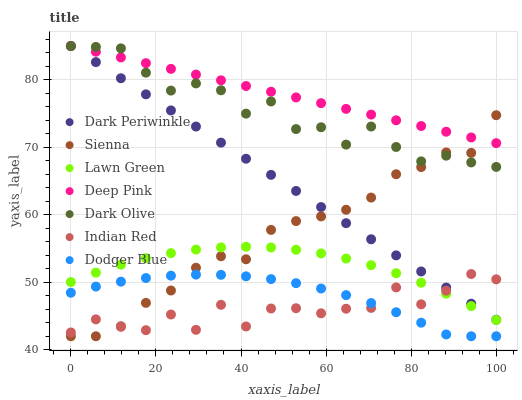Does Indian Red have the minimum area under the curve?
Answer yes or no. Yes. Does Deep Pink have the maximum area under the curve?
Answer yes or no. Yes. Does Dark Olive have the minimum area under the curve?
Answer yes or no. No. Does Dark Olive have the maximum area under the curve?
Answer yes or no. No. Is Deep Pink the smoothest?
Answer yes or no. Yes. Is Indian Red the roughest?
Answer yes or no. Yes. Is Dark Olive the smoothest?
Answer yes or no. No. Is Dark Olive the roughest?
Answer yes or no. No. Does Sienna have the lowest value?
Answer yes or no. Yes. Does Dark Olive have the lowest value?
Answer yes or no. No. Does Dark Periwinkle have the highest value?
Answer yes or no. Yes. Does Sienna have the highest value?
Answer yes or no. No. Is Dodger Blue less than Lawn Green?
Answer yes or no. Yes. Is Dark Olive greater than Dodger Blue?
Answer yes or no. Yes. Does Dark Periwinkle intersect Sienna?
Answer yes or no. Yes. Is Dark Periwinkle less than Sienna?
Answer yes or no. No. Is Dark Periwinkle greater than Sienna?
Answer yes or no. No. Does Dodger Blue intersect Lawn Green?
Answer yes or no. No. 